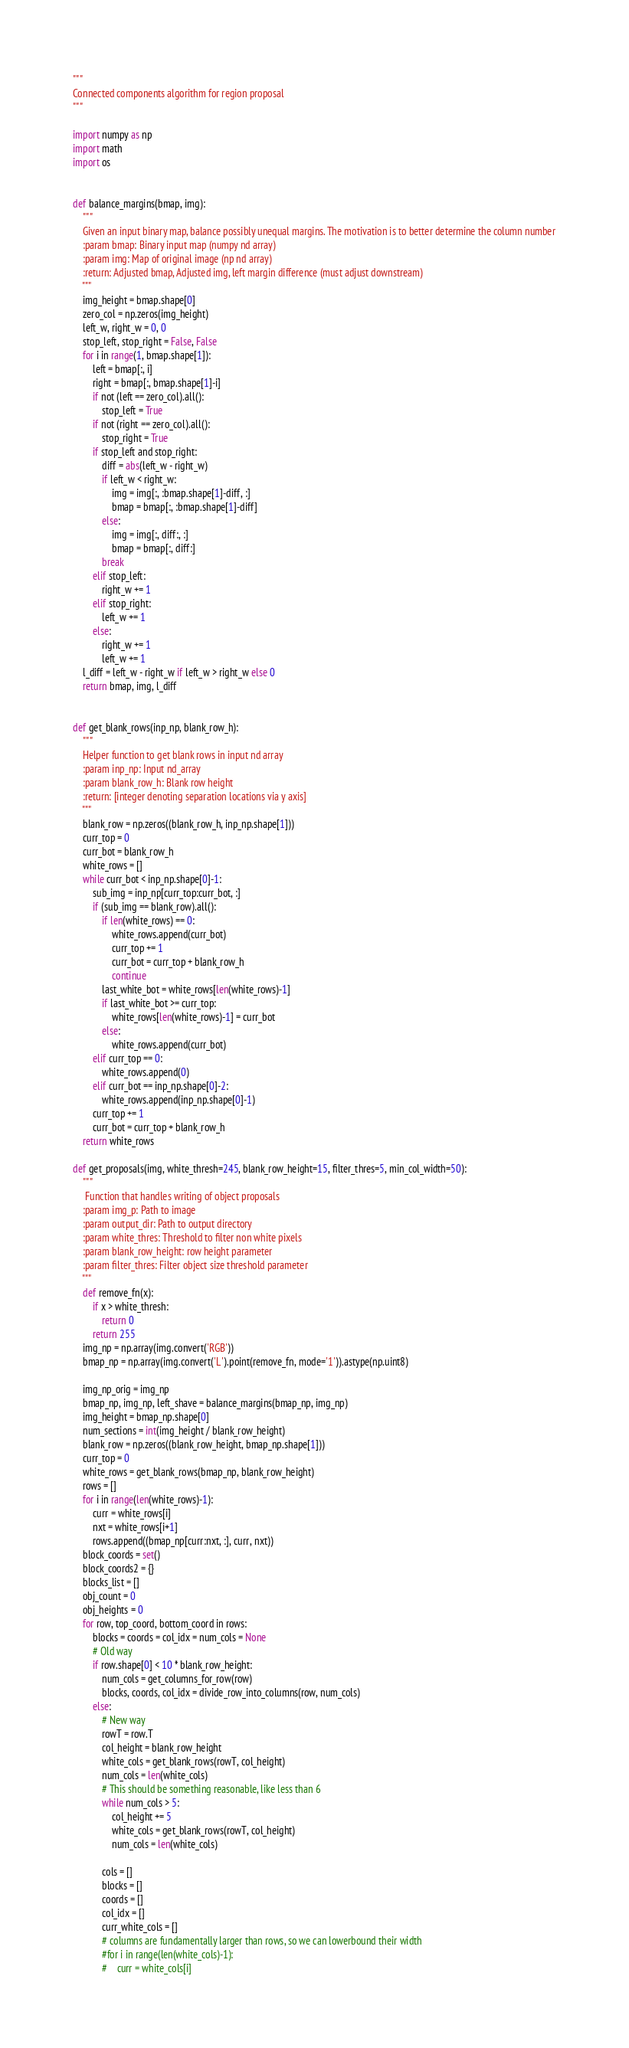<code> <loc_0><loc_0><loc_500><loc_500><_Python_>"""
Connected components algorithm for region proposal
"""

import numpy as np
import math
import os


def balance_margins(bmap, img):
    """
    Given an input binary map, balance possibly unequal margins. The motivation is to better determine the column number
    :param bmap: Binary input map (numpy nd array)
    :param img: Map of original image (np nd array)
    :return: Adjusted bmap, Adjusted img, left margin difference (must adjust downstream)
    """
    img_height = bmap.shape[0]
    zero_col = np.zeros(img_height)
    left_w, right_w = 0, 0
    stop_left, stop_right = False, False
    for i in range(1, bmap.shape[1]):
        left = bmap[:, i]
        right = bmap[:, bmap.shape[1]-i]
        if not (left == zero_col).all():
            stop_left = True
        if not (right == zero_col).all():
            stop_right = True
        if stop_left and stop_right:
            diff = abs(left_w - right_w)
            if left_w < right_w:
                img = img[:, :bmap.shape[1]-diff, :]
                bmap = bmap[:, :bmap.shape[1]-diff]
            else:
                img = img[:, diff:, :]
                bmap = bmap[:, diff:]
            break
        elif stop_left:
            right_w += 1
        elif stop_right:
            left_w += 1
        else:
            right_w += 1
            left_w += 1
    l_diff = left_w - right_w if left_w > right_w else 0
    return bmap, img, l_diff


def get_blank_rows(inp_np, blank_row_h):
    """
    Helper function to get blank rows in input nd array
    :param inp_np: Input nd_array
    :param blank_row_h: Blank row height
    :return: [integer denoting separation locations via y axis]
    """
    blank_row = np.zeros((blank_row_h, inp_np.shape[1]))
    curr_top = 0
    curr_bot = blank_row_h
    white_rows = []
    while curr_bot < inp_np.shape[0]-1:
        sub_img = inp_np[curr_top:curr_bot, :]
        if (sub_img == blank_row).all():
            if len(white_rows) == 0:
                white_rows.append(curr_bot)
                curr_top += 1
                curr_bot = curr_top + blank_row_h
                continue
            last_white_bot = white_rows[len(white_rows)-1]
            if last_white_bot >= curr_top:
                white_rows[len(white_rows)-1] = curr_bot
            else:
                white_rows.append(curr_bot)
        elif curr_top == 0:
            white_rows.append(0)
        elif curr_bot == inp_np.shape[0]-2:
            white_rows.append(inp_np.shape[0]-1)
        curr_top += 1
        curr_bot = curr_top + blank_row_h
    return white_rows

def get_proposals(img, white_thresh=245, blank_row_height=15, filter_thres=5, min_col_width=50):
    """
     Function that handles writing of object proposals
    :param img_p: Path to image
    :param output_dir: Path to output directory
    :param white_thres: Threshold to filter non white pixels
    :param blank_row_height: row height parameter
    :param filter_thres: Filter object size threshold parameter
    """
    def remove_fn(x):
        if x > white_thresh:
            return 0
        return 255
    img_np = np.array(img.convert('RGB'))
    bmap_np = np.array(img.convert('L').point(remove_fn, mode='1')).astype(np.uint8)

    img_np_orig = img_np
    bmap_np, img_np, left_shave = balance_margins(bmap_np, img_np)
    img_height = bmap_np.shape[0]
    num_sections = int(img_height / blank_row_height)
    blank_row = np.zeros((blank_row_height, bmap_np.shape[1]))
    curr_top = 0
    white_rows = get_blank_rows(bmap_np, blank_row_height)
    rows = []
    for i in range(len(white_rows)-1):
        curr = white_rows[i]
        nxt = white_rows[i+1]
        rows.append((bmap_np[curr:nxt, :], curr, nxt))
    block_coords = set()
    block_coords2 = {}
    blocks_list = []
    obj_count = 0
    obj_heights = 0
    for row, top_coord, bottom_coord in rows:
        blocks = coords = col_idx = num_cols = None
        # Old way
        if row.shape[0] < 10 * blank_row_height:
            num_cols = get_columns_for_row(row)
            blocks, coords, col_idx = divide_row_into_columns(row, num_cols)
        else:
            # New way
            rowT = row.T
            col_height = blank_row_height
            white_cols = get_blank_rows(rowT, col_height)
            num_cols = len(white_cols)
            # This should be something reasonable, like less than 6
            while num_cols > 5:
                col_height += 5
                white_cols = get_blank_rows(rowT, col_height)
                num_cols = len(white_cols)

            cols = []
            blocks = []
            coords = []
            col_idx = []
            curr_white_cols = []
            # columns are fundamentally larger than rows, so we can lowerbound their width
            #for i in range(len(white_cols)-1):
            #    curr = white_cols[i]</code> 